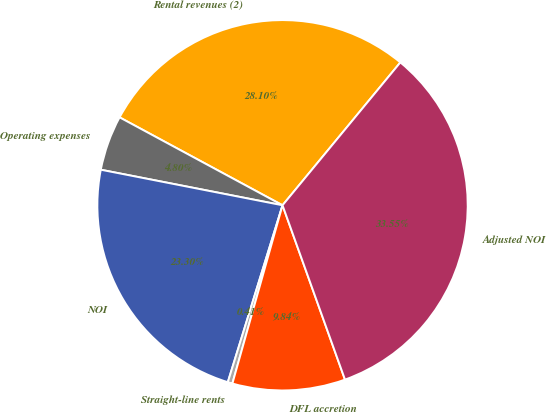<chart> <loc_0><loc_0><loc_500><loc_500><pie_chart><fcel>Rental revenues (2)<fcel>Operating expenses<fcel>NOI<fcel>Straight-line rents<fcel>DFL accretion<fcel>Adjusted NOI<nl><fcel>28.1%<fcel>4.8%<fcel>23.3%<fcel>0.41%<fcel>9.84%<fcel>33.55%<nl></chart> 